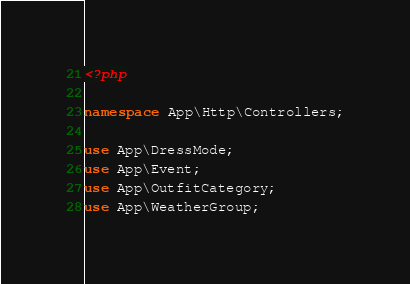<code> <loc_0><loc_0><loc_500><loc_500><_PHP_><?php

namespace App\Http\Controllers;

use App\DressMode;
use App\Event;
use App\OutfitCategory;
use App\WeatherGroup;</code> 